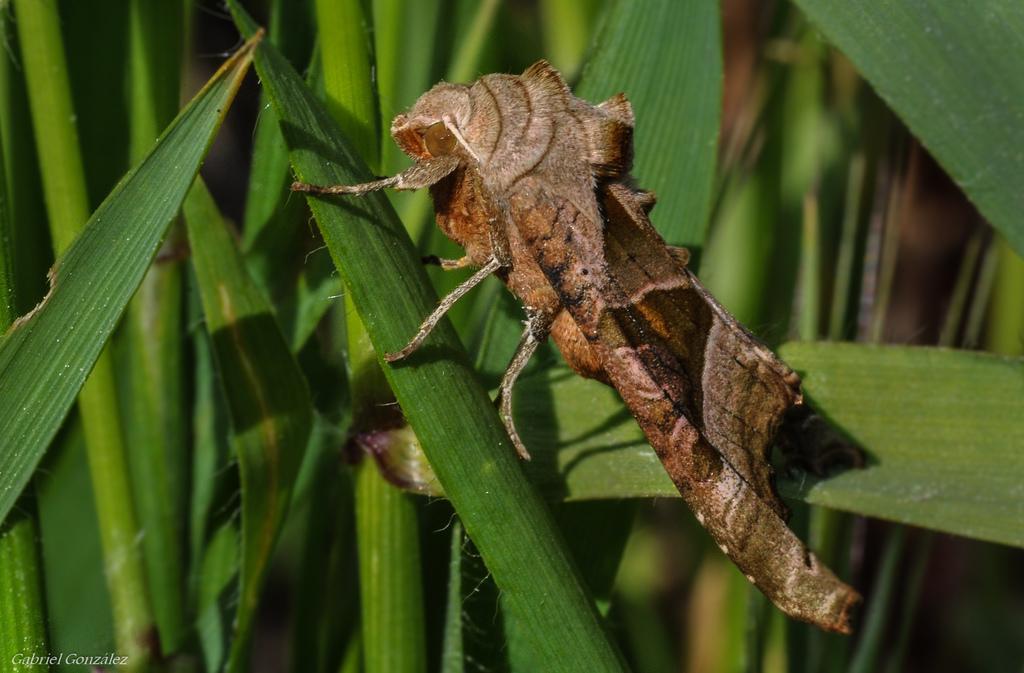Describe this image in one or two sentences. This picture contains an insect and it looks like a silk moth. It is on the leaf of the plant. In the background, we see the plants or the trees. It is blurred in the background. 